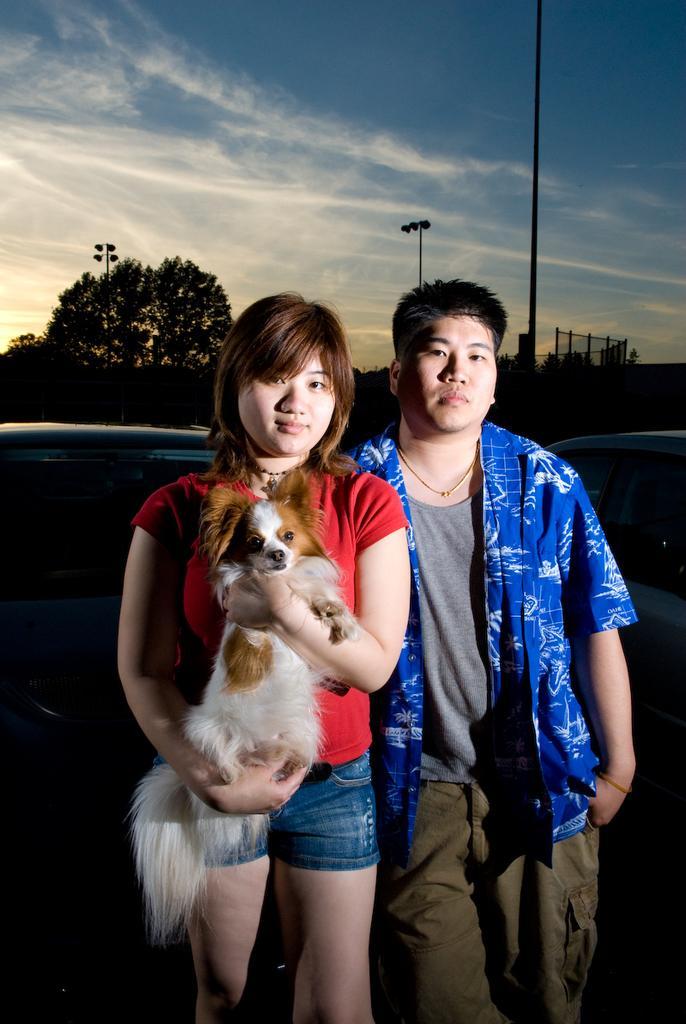Could you give a brief overview of what you see in this image? Here in this picture we can see two people. To the left side there is a lady. She is holding a puppy in her hands. She is wearing a red t-shirt. And to the right side there is man with blue shirt and grey t-shirt. We can see a blue sky. And in the background we can see trees and electrical poles. To the back of these persons there is a car. 